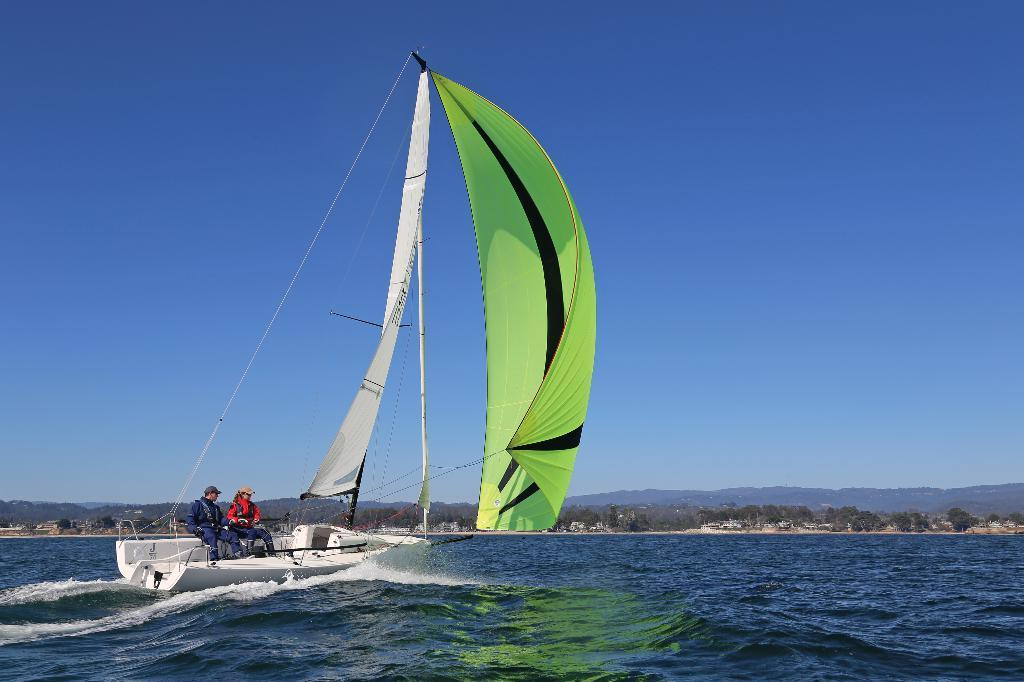What is the main setting of the image? There is an ocean in the image. What is on the ocean in the image? There is a boat on the ocean. How many people are on the boat? There are two persons sitting on the boat. What can be seen in the background of the image? The sky and trees are visible in the background of the image. How does the boat grip the ocean during its voyage in the image? The boat does not grip the ocean; it floats on the water's surface. Additionally, there is no mention of a voyage in the provided facts. 